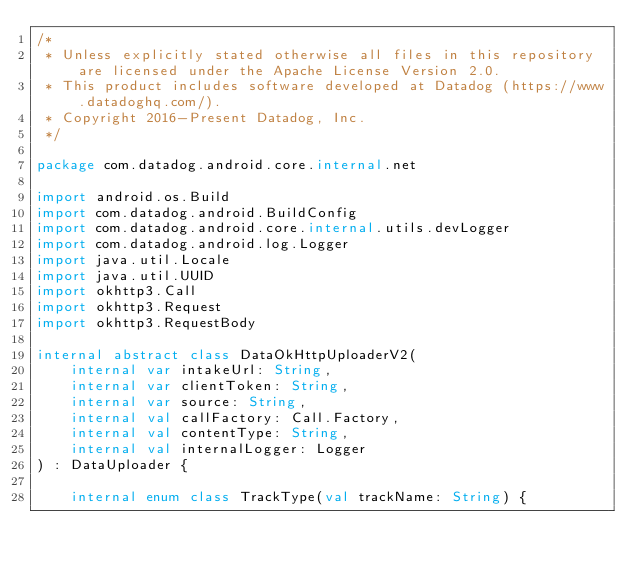<code> <loc_0><loc_0><loc_500><loc_500><_Kotlin_>/*
 * Unless explicitly stated otherwise all files in this repository are licensed under the Apache License Version 2.0.
 * This product includes software developed at Datadog (https://www.datadoghq.com/).
 * Copyright 2016-Present Datadog, Inc.
 */

package com.datadog.android.core.internal.net

import android.os.Build
import com.datadog.android.BuildConfig
import com.datadog.android.core.internal.utils.devLogger
import com.datadog.android.log.Logger
import java.util.Locale
import java.util.UUID
import okhttp3.Call
import okhttp3.Request
import okhttp3.RequestBody

internal abstract class DataOkHttpUploaderV2(
    internal var intakeUrl: String,
    internal var clientToken: String,
    internal var source: String,
    internal val callFactory: Call.Factory,
    internal val contentType: String,
    internal val internalLogger: Logger
) : DataUploader {

    internal enum class TrackType(val trackName: String) {</code> 